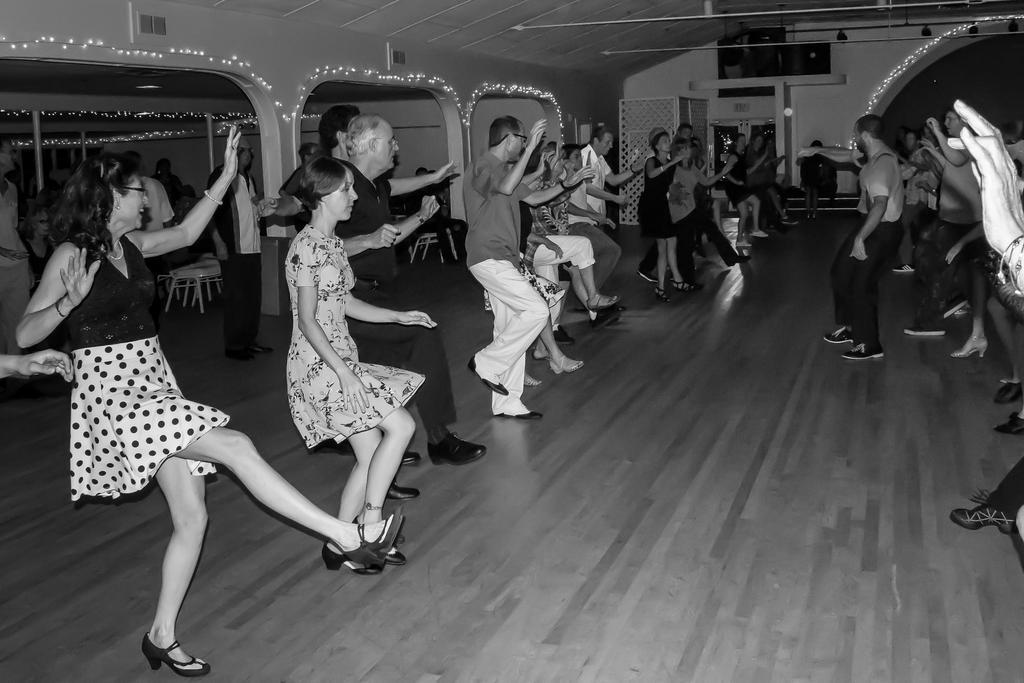How would you summarize this image in a sentence or two? In this picture we can observe some people dancing on the floor. There are men and women in this picture. We can observe some lights decorated on the wall. This is a black and white image. 